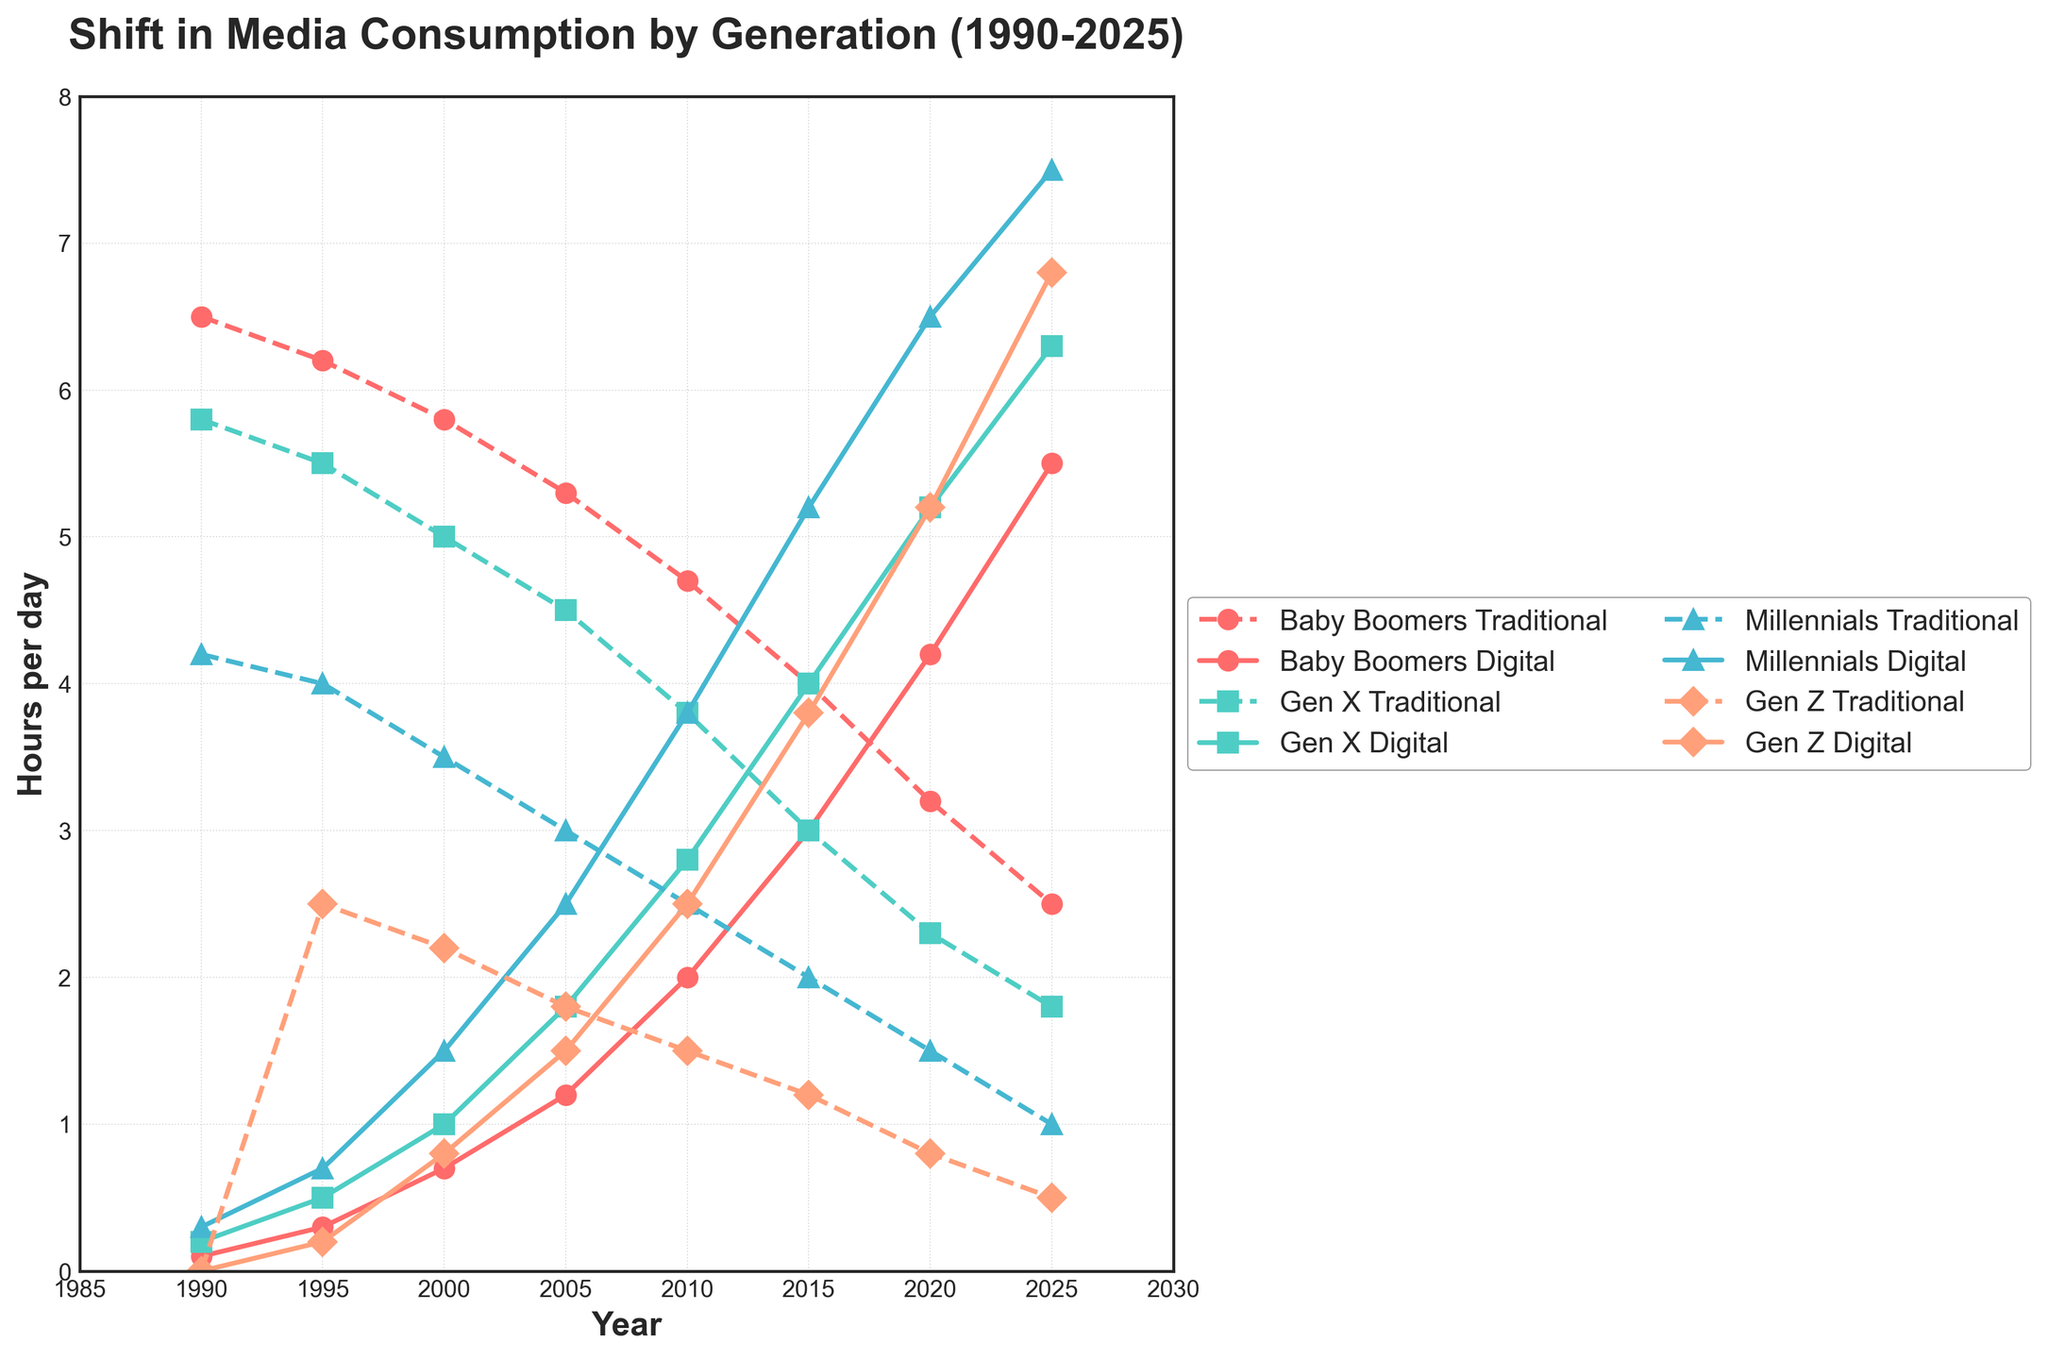Which generation had the highest traditional media consumption in 2025? Look at the plot for 2025 and find the highest data point among the four generations' traditional media lines. The blue line (Baby Boomers) seems to have the highest value.
Answer: Baby Boomers How did traditional media consumption for Gen X change from 1990 to 2025? Compare the traditional media values for Gen X in 1990 and 2025. Subtract the 2025 value from the 1990 value to see the change.
Answer: Decreased by 4.0 hours In 2020, which generation spent more time on digital media compared to traditional media? Compare the digital and traditional media values for each generation in 2020. Identify any generation where the digital line is higher than the traditional line.
Answer: Millennials What was the total media consumption (traditional + digital) for Millennials in 2015? Find the traditional and digital media values for Millennials in 2015 and add them together. Traditional media: 2.0 hours, Digital media: 5.2 hours. Total: 2.0 + 5.2 = 7.2 hours.
Answer: 7.2 hours Between 2010 and 2020, how much did the digital media consumption of Gen Z change? Compare the digital media values for Gen Z in 2010 and 2020. Subtract the 2010 value from the 2020 value.
Answer: Increased by 2.7 hours Which generation experienced the largest decrease in traditional media consumption from 1990 to 2025? Calculate the decrease in traditional media consumption for each generation from 1990 to 2025, and identify the largest difference. Baby Boomers: 6.5 - 2.5 = 4.0, Gen X: 5.8 - 1.8 = 4.0, Millennials: 4.2 - 1.0 = 3.2, Gen Z: 2.5 - 0.5 = 2.0.
Answer: Baby Boomers and Gen X In 2000, which generation had the smallest difference between traditional and digital media consumption? For each generation in 2000, calculate the difference between traditional and digital media consumption. Identify the smallest difference.
Answer: Gen Z By how many hours did the traditional media consumption of Baby Boomers decrease each decade from 1990 to 2025? Calculate the difference in consumption for each decade and take the average. (6.5-5.8=0.7, 5.8-5.3=0.5, 5.3-4.7=0.6, 4.7-4.0=0.7, 4.0-3.2=0.8, 3.2-2.5=0.7). Average: (0.7+0.5+0.6+0.7+0.8+0.7)/6 = 0.67 hours.
Answer: 0.67 hours per decade What's the average digital media consumption for Gen X from 2000 to 2020? Sum the digital media consumption values for Gen X from 2000, 2005, 2010, 2015, and 2020, then divide by the number of data points. (1.0 + 1.8 + 2.8 + 4.0 + 5.2) / 5 = 2.96.
Answer: 2.96 hours What is the gap in hours between the traditional media consumption of Baby Boomers and Gen Z in 2025? Subtract the traditional media consumption value of Gen Z from that of Baby Boomers in 2025. 2.5 - 0.5 = 2.0 hours.
Answer: 2.0 hours 